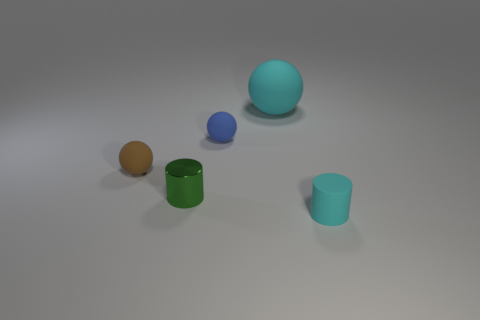Add 2 big gray matte cubes. How many objects exist? 7 Subtract all small spheres. How many spheres are left? 1 Add 2 big red matte blocks. How many big red matte blocks exist? 2 Subtract all cyan balls. How many balls are left? 2 Subtract 0 purple cylinders. How many objects are left? 5 Subtract all spheres. How many objects are left? 2 Subtract 2 balls. How many balls are left? 1 Subtract all yellow balls. Subtract all red cubes. How many balls are left? 3 Subtract all blue cylinders. How many blue spheres are left? 1 Subtract all cyan matte cylinders. Subtract all matte spheres. How many objects are left? 1 